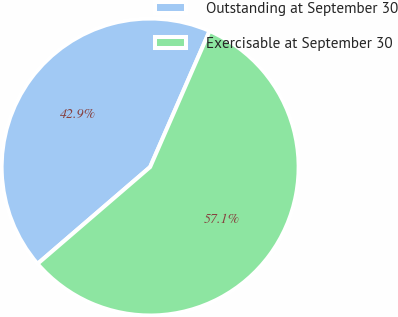Convert chart. <chart><loc_0><loc_0><loc_500><loc_500><pie_chart><fcel>Outstanding at September 30<fcel>Exercisable at September 30<nl><fcel>42.86%<fcel>57.14%<nl></chart> 